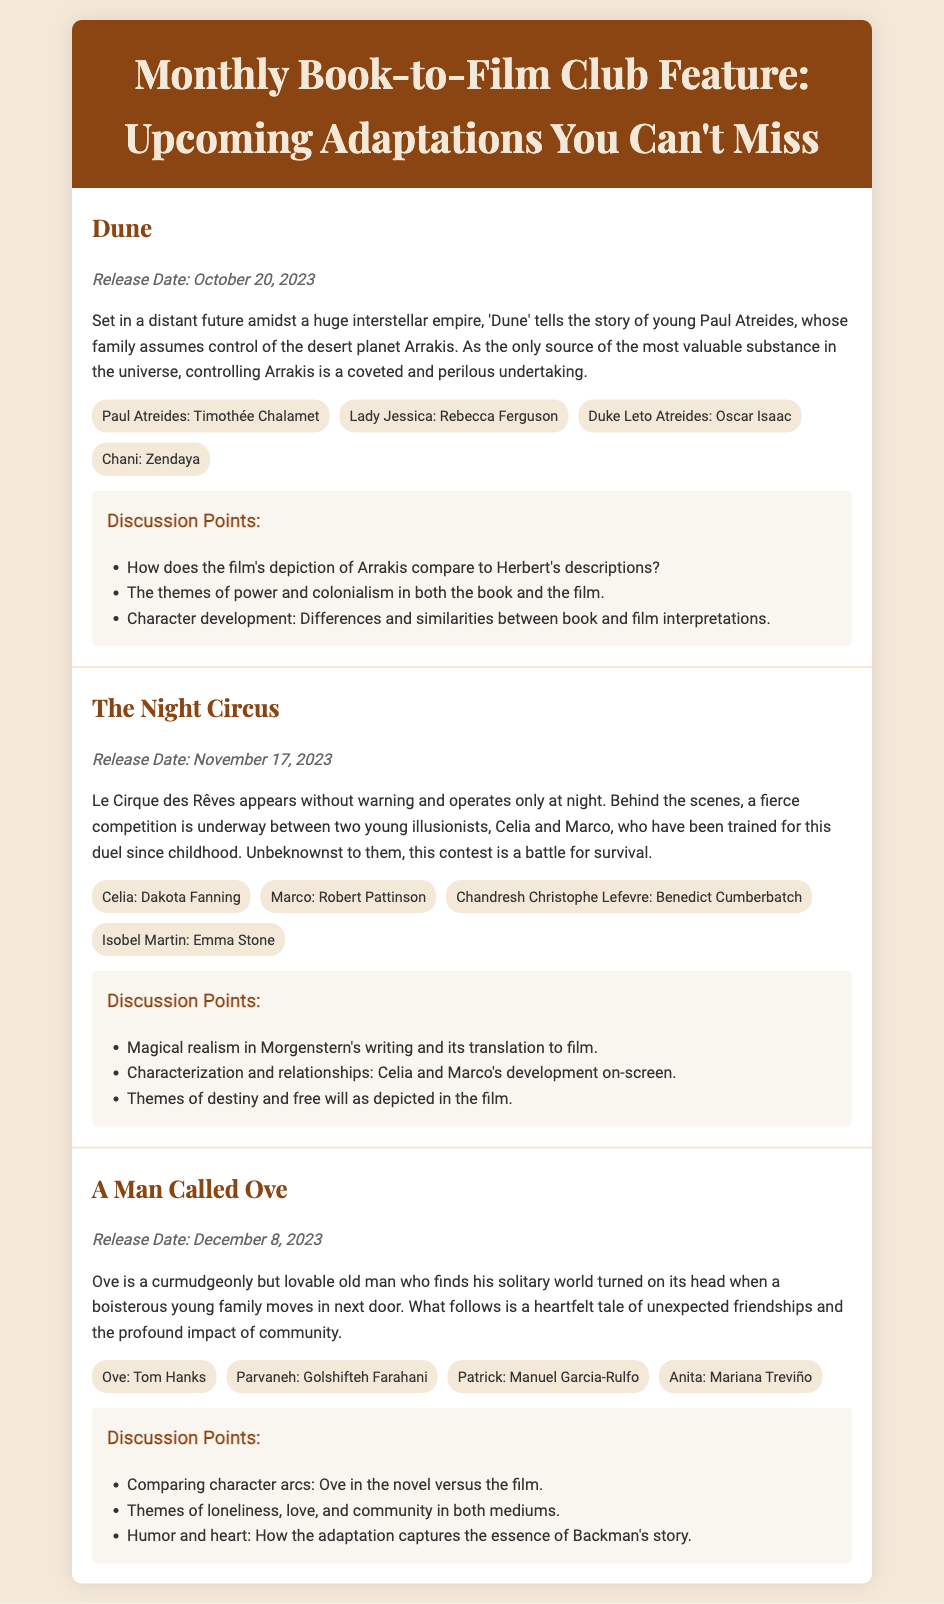What is the release date for "Dune"? The document states that "Dune" will be released on October 20, 2023.
Answer: October 20, 2023 Who plays the character Celia in "The Night Circus"? The Playbill lists Dakota Fanning as the actor portraying Celia.
Answer: Dakota Fanning What are the names of the main characters competing in "The Night Circus"? The document specifies that the main characters are Celia and Marco.
Answer: Celia and Marco How does Ove's character in "A Man Called Ove" change? The discussion point highlights comparing his character arcs between the novel and the film, suggesting a transformation.
Answer: Comparison of character arcs Which film adaptation is based on a story about a curmudgeonly man? The Playbill indicates that "A Man Called Ove" features this narrative.
Answer: A Man Called Ove What major theme is explored in both "Dune" and "The Night Circus"? The discussion points for both adaptations mention themes of power, colonialism, and others that reflect on human experiences.
Answer: Themes of power and relationships Who is the director of the adaptations listed? The document does not specify the director's name but focuses on actors and discussion points.
Answer: Not specified What is the narrative setting of "Dune"? The synopsis describes it taking place in a "distant future amidst a huge interstellar empire."
Answer: Distant future amidst a huge interstellar empire 